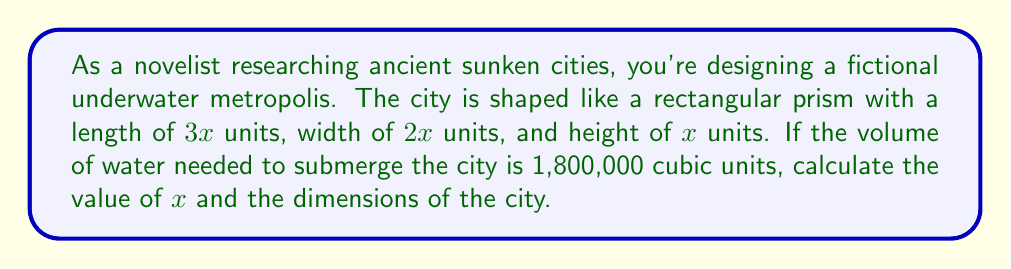Teach me how to tackle this problem. To solve this problem, we'll follow these steps:

1) First, let's recall the formula for the volume of a rectangular prism:
   $$V = l \times w \times h$$
   where $V$ is volume, $l$ is length, $w$ is width, and $h$ is height.

2) We're given that:
   - Length = $3x$
   - Width = $2x$
   - Height = $x$
   - Volume = 1,800,000 cubic units

3) Let's substitute these into our volume formula:
   $$1,800,000 = 3x \times 2x \times x$$

4) Simplify the right side of the equation:
   $$1,800,000 = 6x^3$$

5) Divide both sides by 6:
   $$300,000 = x^3$$

6) Take the cube root of both sides:
   $$\sqrt[3]{300,000} = x$$

7) Calculate the value of $x$:
   $$x = 66.94$$  (rounded to two decimal places)

8) Now that we know $x$, we can calculate the dimensions:
   - Length = $3x = 3 \times 66.94 = 200.82$ units
   - Width = $2x = 2 \times 66.94 = 133.88$ units
   - Height = $x = 66.94$ units
Answer: $x = 66.94$ units; Length = 200.82 units, Width = 133.88 units, Height = 66.94 units 